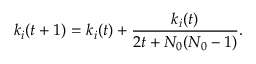Convert formula to latex. <formula><loc_0><loc_0><loc_500><loc_500>k _ { i } ( t + 1 ) = k _ { i } ( t ) + \frac { k _ { i } ( t ) } { 2 t + N _ { 0 } ( N _ { 0 } - 1 ) } .</formula> 